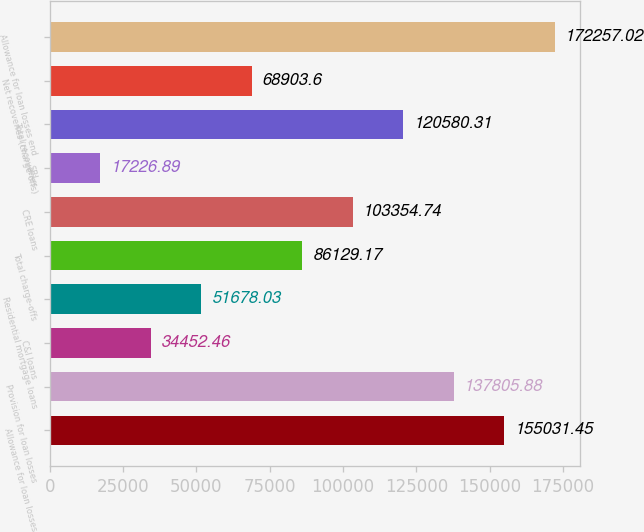Convert chart. <chart><loc_0><loc_0><loc_500><loc_500><bar_chart><fcel>Allowance for loan losses<fcel>Provision for loan losses<fcel>C&I loans<fcel>Residential mortgage loans<fcel>Total charge-offs<fcel>CRE loans<fcel>SBL<fcel>Total recoveries<fcel>Net recoveries (charge-offs)<fcel>Allowance for loan losses end<nl><fcel>155031<fcel>137806<fcel>34452.5<fcel>51678<fcel>86129.2<fcel>103355<fcel>17226.9<fcel>120580<fcel>68903.6<fcel>172257<nl></chart> 